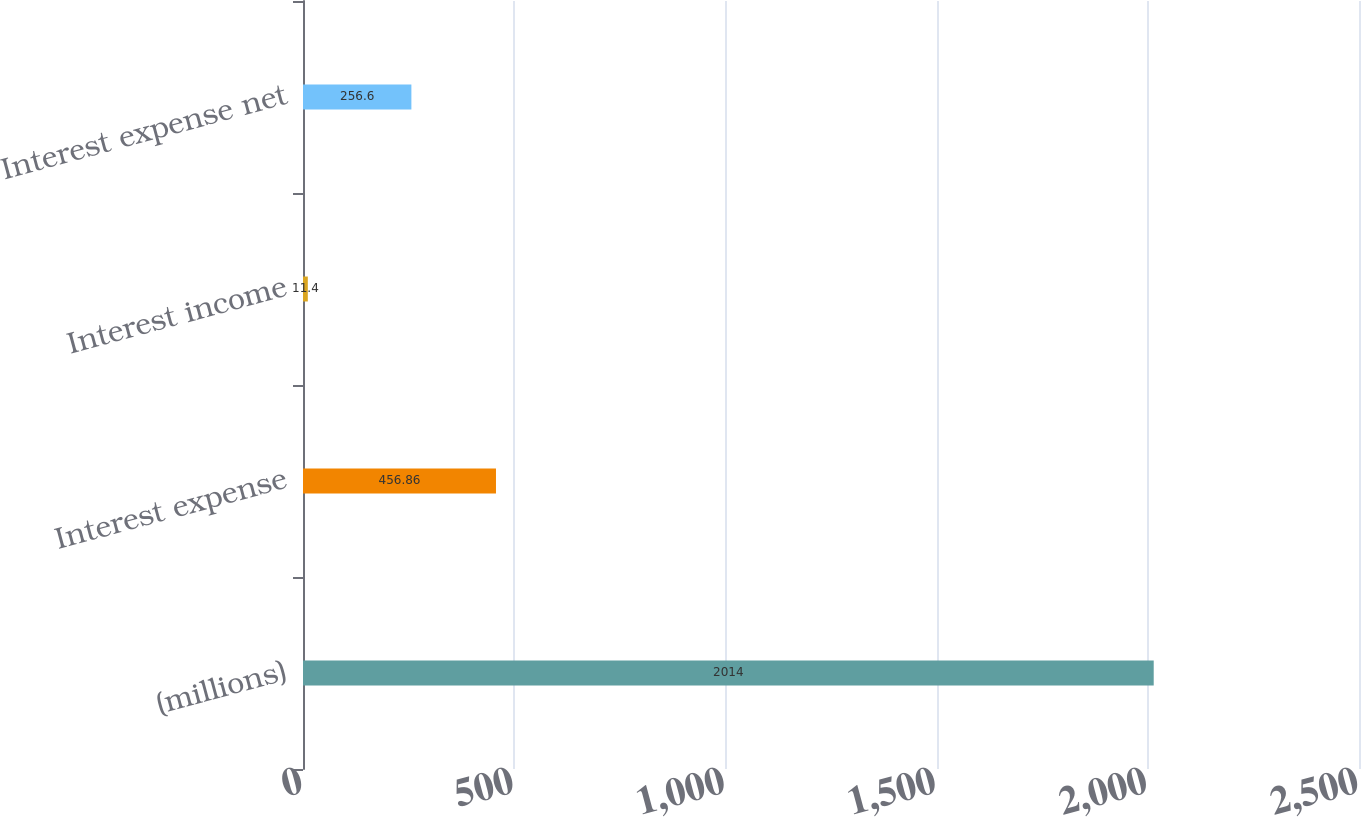<chart> <loc_0><loc_0><loc_500><loc_500><bar_chart><fcel>(millions)<fcel>Interest expense<fcel>Interest income<fcel>Interest expense net<nl><fcel>2014<fcel>456.86<fcel>11.4<fcel>256.6<nl></chart> 